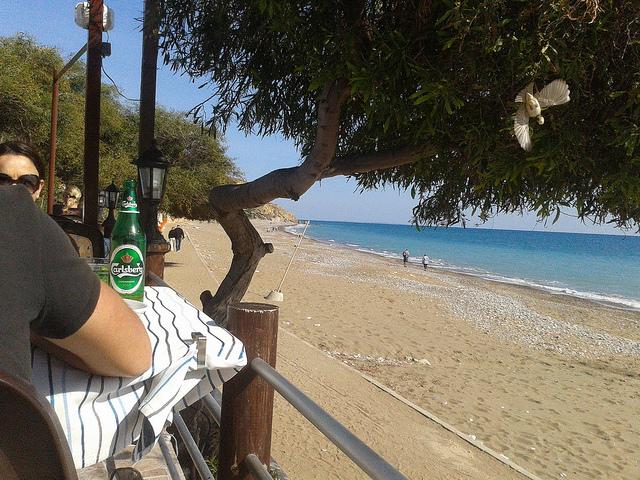What is inside the green bottle on the table? Please explain your reasoning. beer. The beer is inside. 